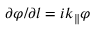Convert formula to latex. <formula><loc_0><loc_0><loc_500><loc_500>\partial \varphi / \partial l = i k _ { \| } \varphi</formula> 